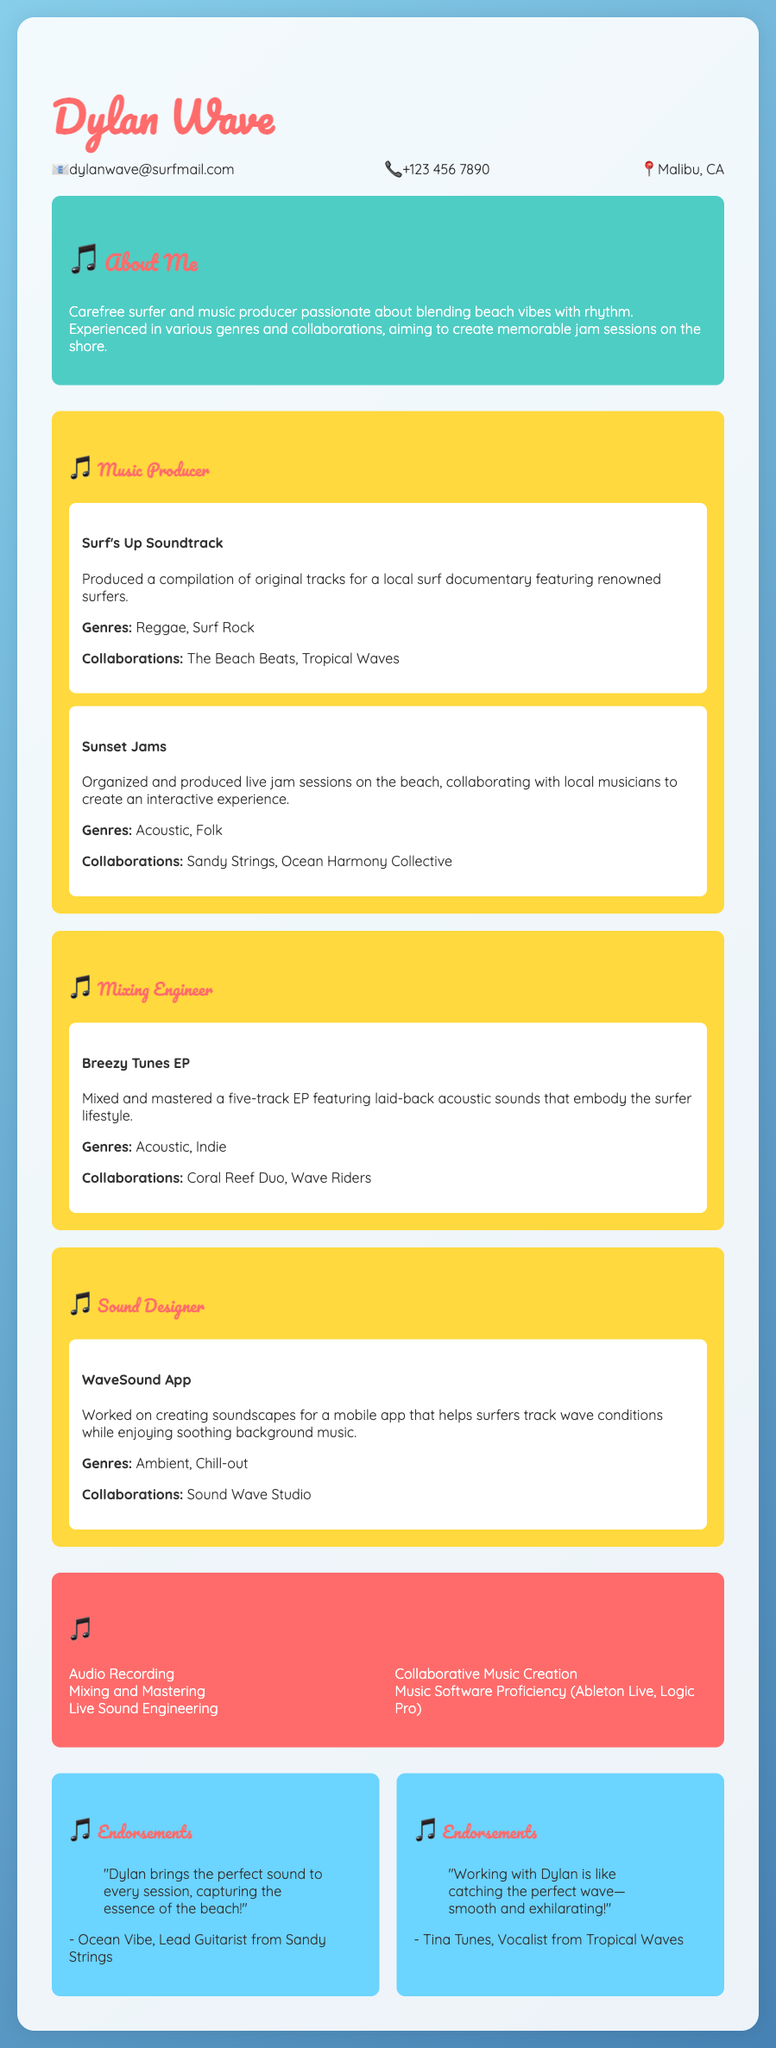What is the name of the music producer? The name of the music producer is stated at the top of the document as Dylan Wave.
Answer: Dylan Wave What is Dylan’s email address? The email address is listed in the contact information section of the document as dylanwave@surfmail.com.
Answer: dylanwave@surfmail.com What project did Dylan produce for a local surf documentary? The document mentions a specific project called "Surf's Up Soundtrack" that was produced for a local surf documentary.
Answer: Surf's Up Soundtrack Which genres are explored in the "Breezy Tunes EP"? The genres listed for the "Breezy Tunes EP" are Acoustic and Indie.
Answer: Acoustic, Indie How many endorsements are presented in the document? The endorsements section contains two distinct endorsements from different musicians.
Answer: 2 What is the focus of the "WaveSound App" project? The project focuses on creating soundscapes for a mobile app designed to help surfers track wave conditions.
Answer: Soundscapes for a mobile app Who collaborated with Dylan on the "Sunset Jams" project? The collaboration for "Sunset Jams" involved local musicians, specifically named Sandy Strings and Ocean Harmony Collective.
Answer: Sandy Strings, Ocean Harmony Collective What skills are listed in Dylan's CV? The skills section outlines several abilities, including Audio Recording, Mixing and Mastering, and more.
Answer: Audio Recording, Mixing and Mastering.. What is the main vibe that Dylan aims to blend in his music? The document describes Dylan as passionate about blending beach vibes with rhythm in his music production.
Answer: Beach vibes with rhythm What is the location of Dylan as listed in his contact information? The document mentions that Dylan is located in Malibu, CA in the contact information section.
Answer: Malibu, CA 